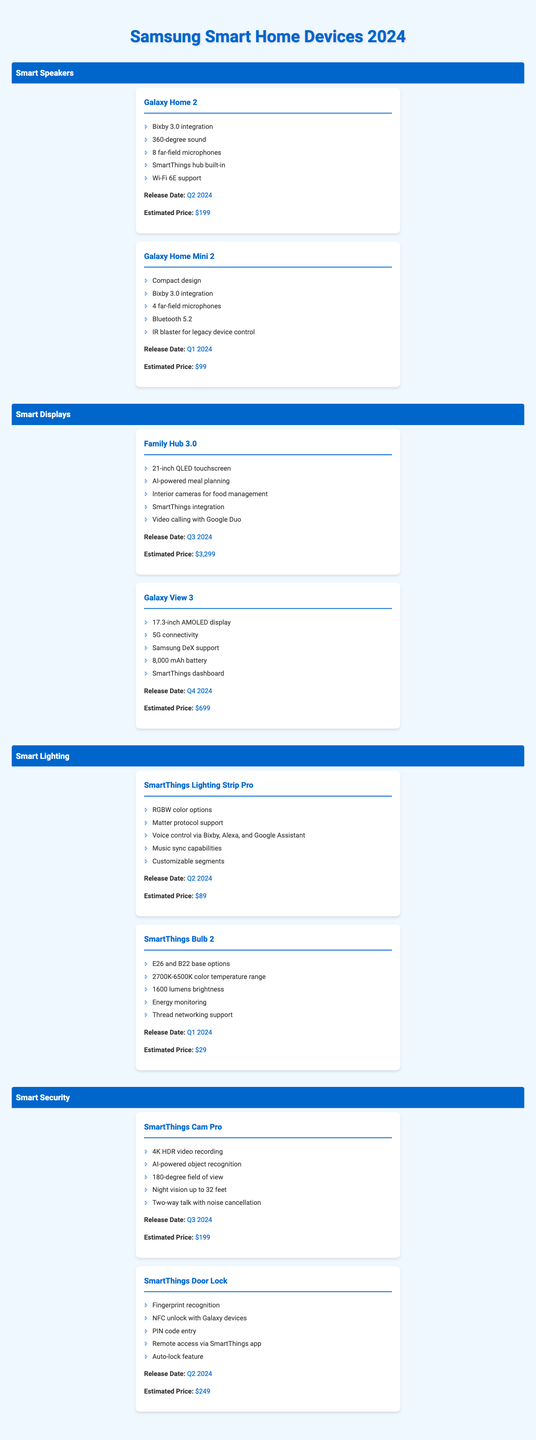What is the release date of the Galaxy Home Mini 2? The table lists the release dates for each device. The Galaxy Home Mini 2 has a release date of Q1 2024.
Answer: Q1 2024 Which smart lighting device has the lowest estimated price? The table shows the estimated prices for all smart lighting devices. The SmartThings Bulb 2 is priced at $29, which is lower than the SmartThings Lighting Strip Pro priced at $89.
Answer: $29 Is the Galaxy Home 2 compatible with Wi-Fi 6E? The table specifically lists the features for each device. The Galaxy Home 2 includes Wi-Fi 6E support as a feature.
Answer: Yes How many far-field microphones does the Family Hub 3.0 have? The table provides detailed features for the Family Hub 3.0, which mentions it does not have far-field microphones, indicating this feature is not available for this model.
Answer: 0 What is the total estimated price of the SmartThings Cam Pro and SmartThings Door Lock combined? First, identify the estimated prices: SmartThings Cam Pro is $199 and SmartThings Door Lock is $249. Adding them gives $199 + $249 = $448.
Answer: $448 Which smart display has the largest screen size? The table indicates the screen sizes for each smart display. The Family Hub 3.0 has a 21-inch screen, while the Galaxy View 3 has a 17.3-inch display. Therefore, the Family Hub 3.0 has the largest screen size.
Answer: Family Hub 3.0 Does the SmartThings Lighting Strip Pro support the Matter protocol? Looking at the features of the SmartThings Lighting Strip Pro, it clearly states support for the Matter protocol.
Answer: Yes What is the average estimated price of all smart speakers listed? The estimated prices for the smart speakers are $199 for the Galaxy Home 2 and $99 for the Galaxy Home Mini 2. The total is $199 + $99 = $298, with 2 models, so the average is $298 / 2 = $149.
Answer: $149 Which device has the highest estimated price among all categories? By reviewing the estimated prices for all devices listed in the table, the Family Hub 3.0 has the highest estimated price at $3,299.
Answer: Family Hub 3.0 Does the Galaxy View 3 support 5G connectivity? The features for the Galaxy View 3 indicate it supports 5G connectivity.
Answer: Yes 